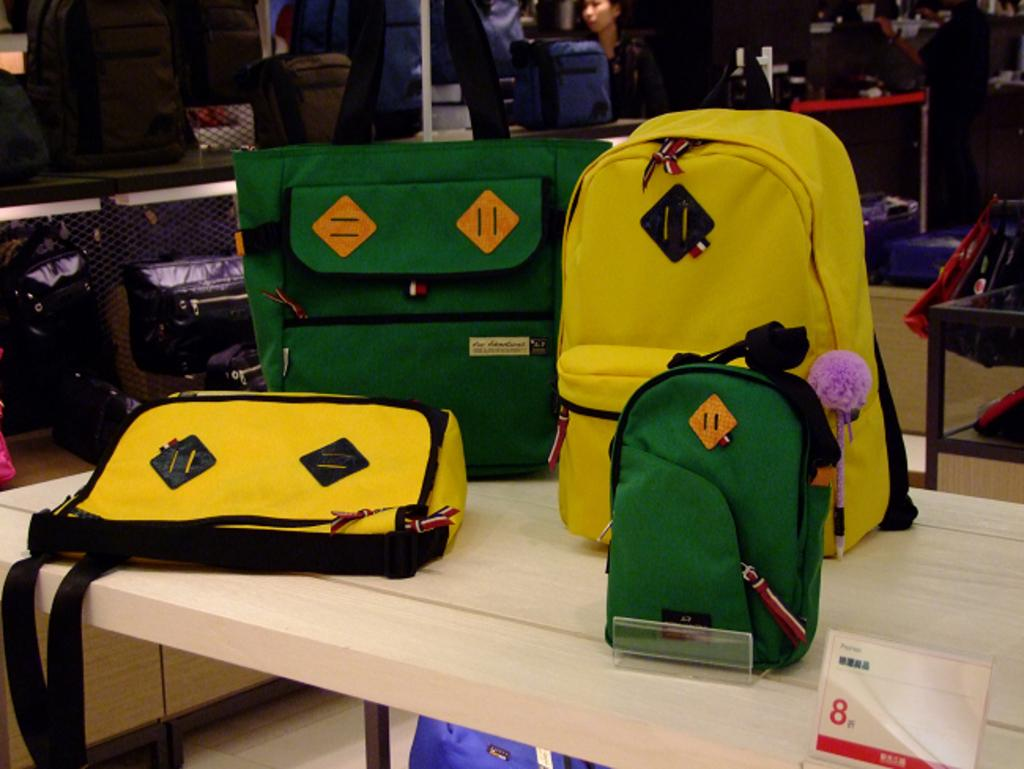What type of furniture is present in the image? There is a table in the image. What is placed on the table? There are bags on the table. What other object can be seen in the image? There is a rack in the image. What is stored on the rack? The rack contains many bags. Where can the pricing information be found in the image? There is a price board in the bottom right corner of the image. What type of cub is visible in the image? There is no cub present in the image. What is the name of the person who owns the bags in the image? The image does not provide any information about the owner of the bags, so we cannot determine their name. 